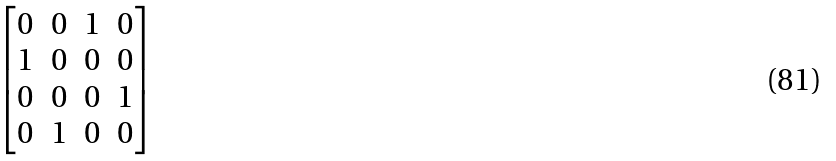<formula> <loc_0><loc_0><loc_500><loc_500>\begin{bmatrix} 0 & 0 & 1 & 0 \\ 1 & 0 & 0 & 0 \\ 0 & 0 & 0 & 1 \\ 0 & 1 & 0 & 0 \end{bmatrix}</formula> 